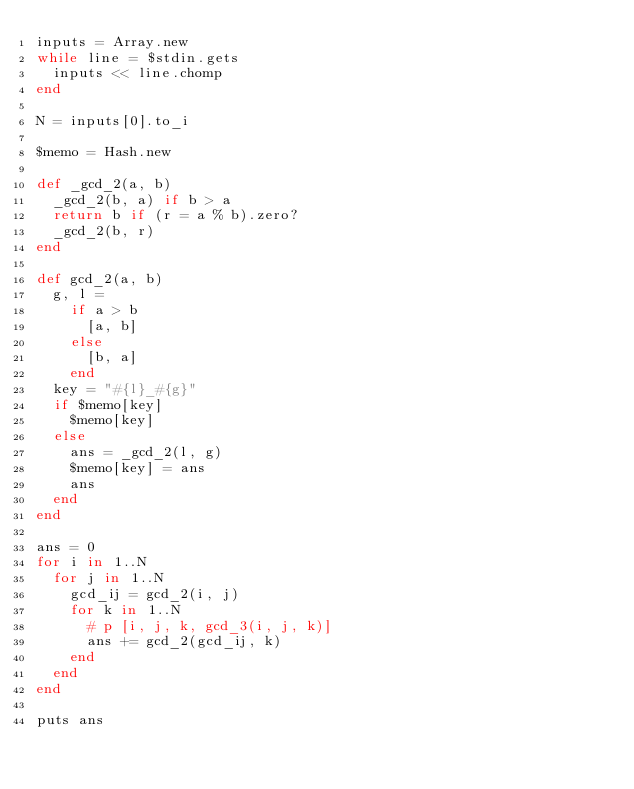Convert code to text. <code><loc_0><loc_0><loc_500><loc_500><_Ruby_>inputs = Array.new
while line = $stdin.gets
  inputs << line.chomp
end

N = inputs[0].to_i

$memo = Hash.new

def _gcd_2(a, b)
  _gcd_2(b, a) if b > a
  return b if (r = a % b).zero?
  _gcd_2(b, r)
end

def gcd_2(a, b)
  g, l =
    if a > b
      [a, b]
    else
      [b, a]
    end
  key = "#{l}_#{g}"
  if $memo[key]
    $memo[key]
  else
    ans = _gcd_2(l, g)
    $memo[key] = ans
    ans
  end
end

ans = 0
for i in 1..N
  for j in 1..N
    gcd_ij = gcd_2(i, j)
    for k in 1..N
      # p [i, j, k, gcd_3(i, j, k)]
      ans += gcd_2(gcd_ij, k)
    end
  end
end

puts ans
</code> 